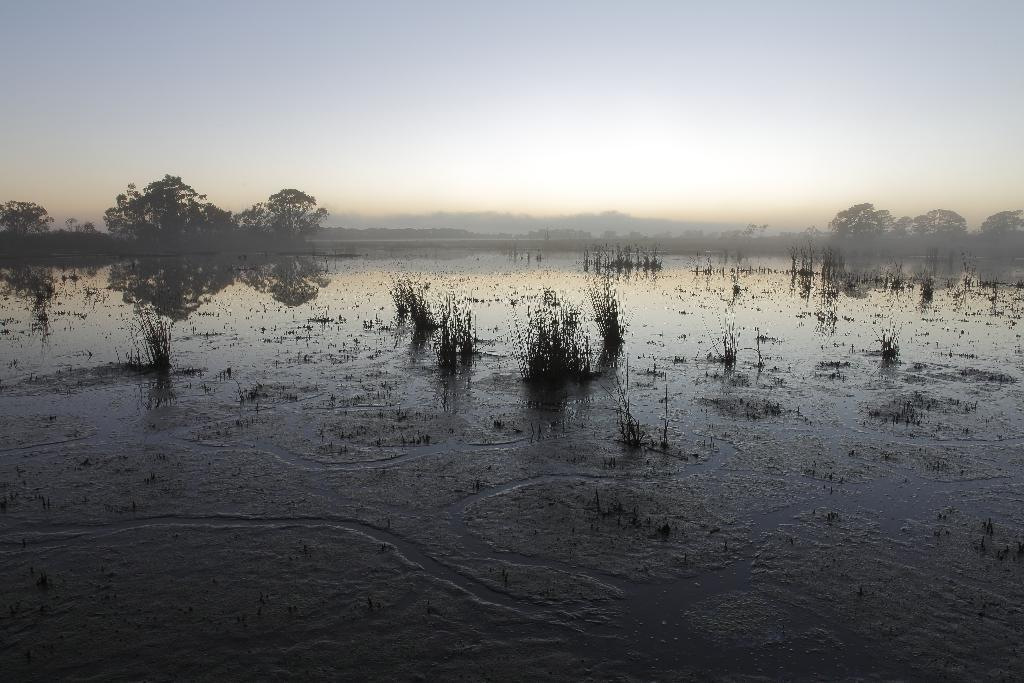Where was the picture taken? The picture was clicked outside the city. What can be seen in the center of the image? There is green grass and a water body in the center of the image. What is visible in the background of the image? The sky, trees, and other unspecified objects are visible in the background of the image. What type of pet can be seen playing with a ball in the image? There is no pet or ball present in the image; it features green grass, a water body, and background elements. 